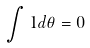<formula> <loc_0><loc_0><loc_500><loc_500>\int 1 d \theta = 0</formula> 